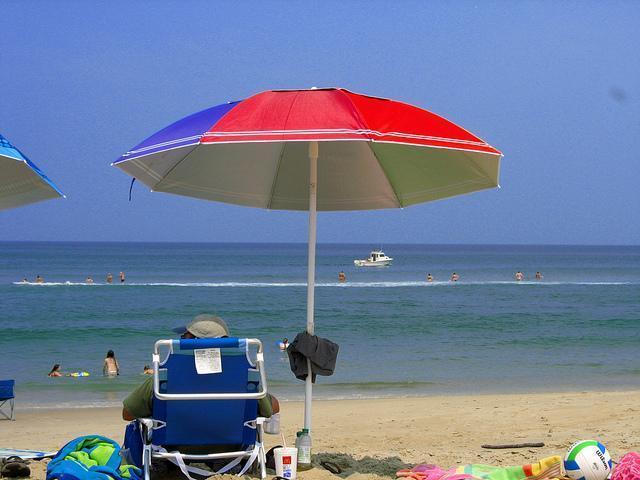How many boats are in this picture?
Give a very brief answer. 1. How many umbrellas are in the picture?
Give a very brief answer. 2. How many chairs can be seen?
Give a very brief answer. 1. 